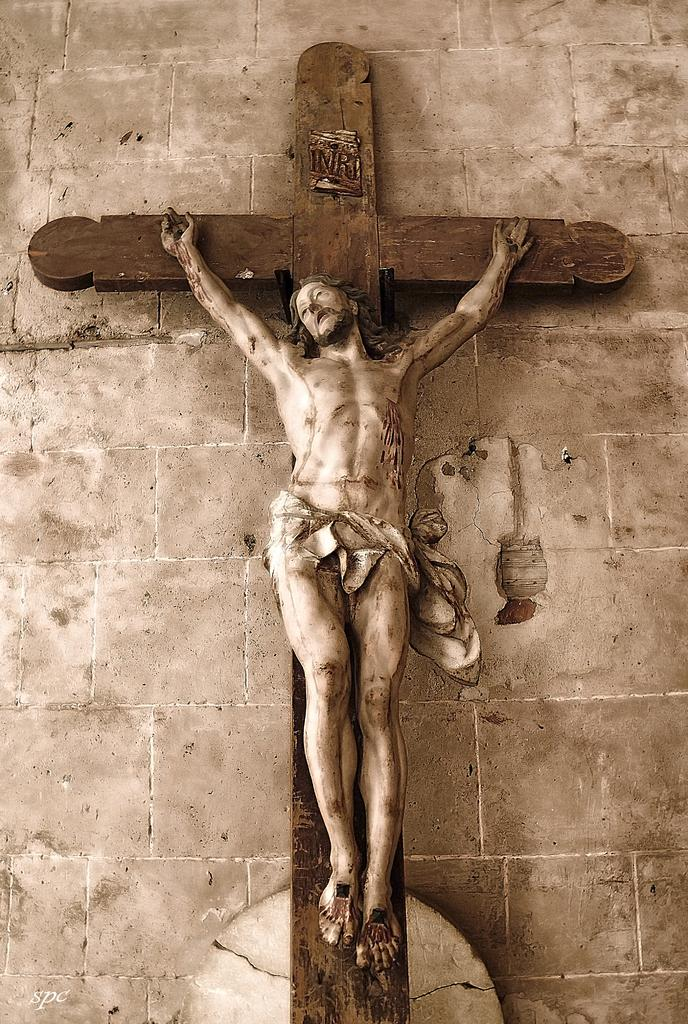What religious symbol can be seen in the image? There is a cross symbol in the image. What figure is depicted in the image? There is a statue of a man in the image. What is visible in the background of the image? There is a wall in the background of the image. How many dogs are present in the image? There are no dogs present in the image. What type of bead is being used by the man in the image? There is no bead present in the image, nor is there a man using a bead. 